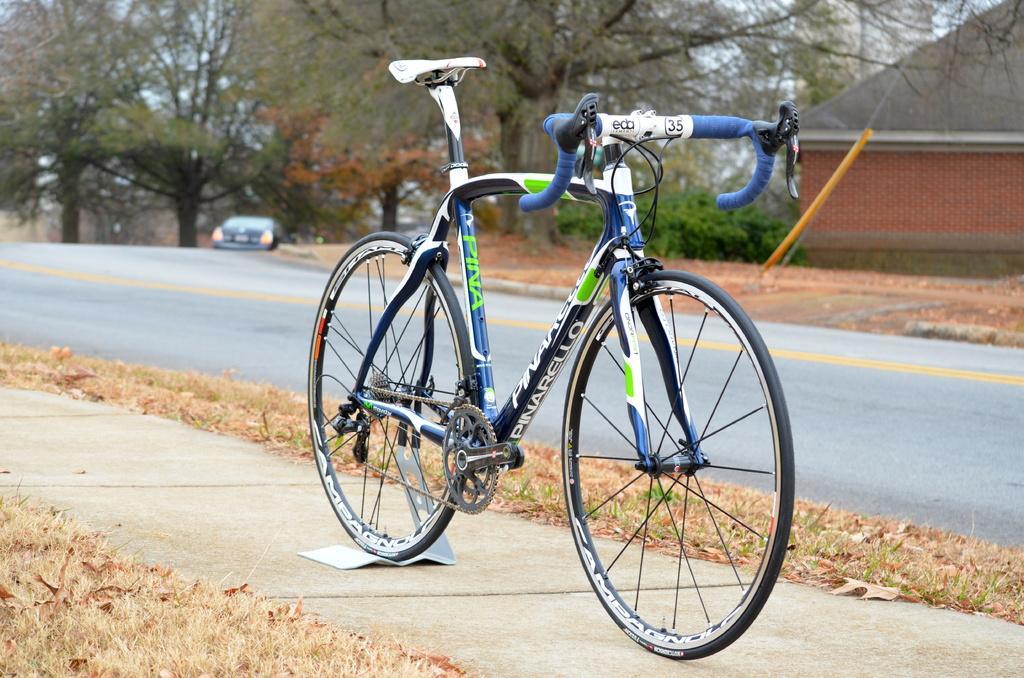In one or two sentences, can you explain what this image depicts? Bicycle is highlighted in this picture. This are trees. These is a vehicle. These is a Road. This is a house with a red bricks. This is a grass. This bicycle contains a chain, wheel, seat and handle. The sky is in blue color. 